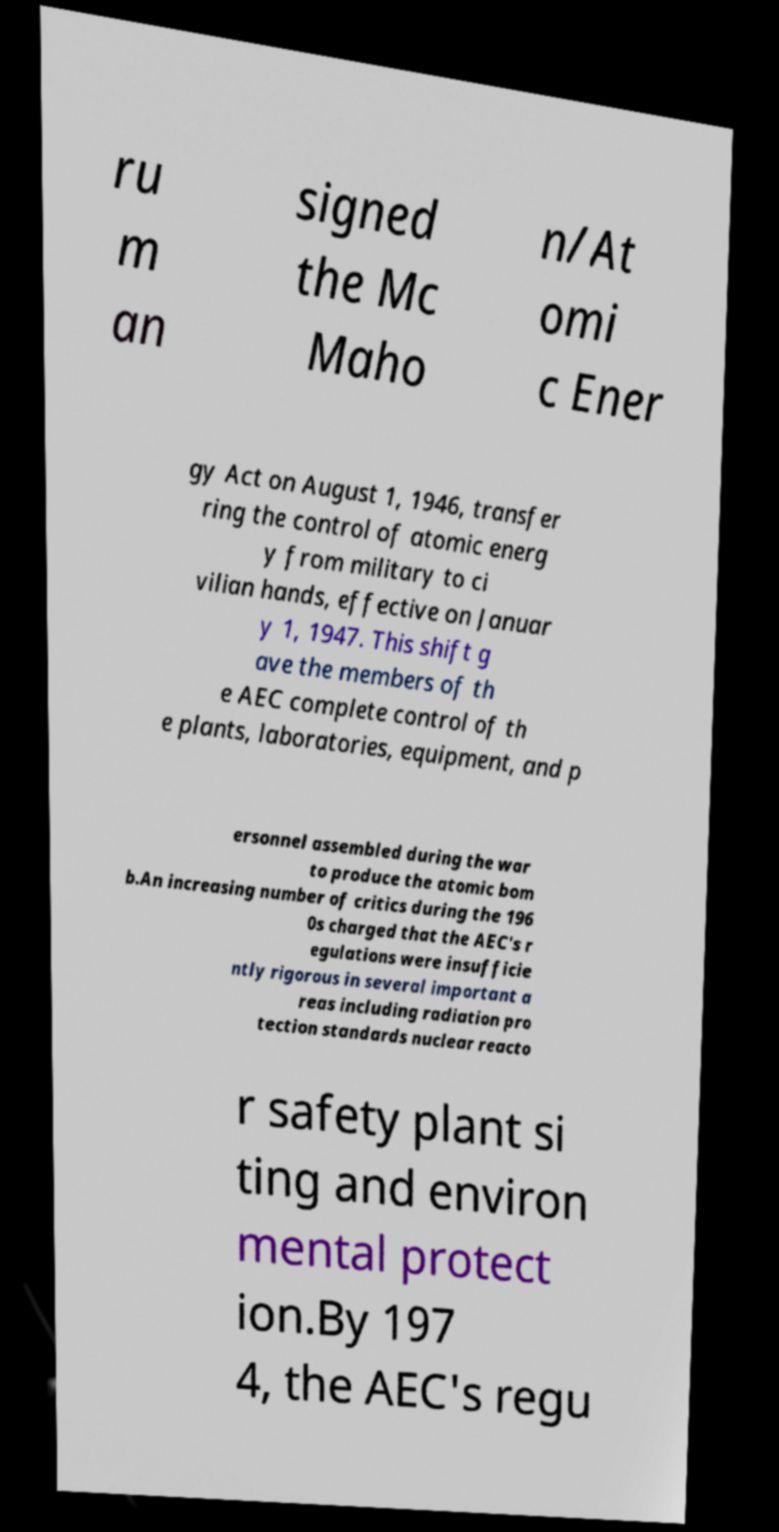Can you read and provide the text displayed in the image?This photo seems to have some interesting text. Can you extract and type it out for me? ru m an signed the Mc Maho n/At omi c Ener gy Act on August 1, 1946, transfer ring the control of atomic energ y from military to ci vilian hands, effective on Januar y 1, 1947. This shift g ave the members of th e AEC complete control of th e plants, laboratories, equipment, and p ersonnel assembled during the war to produce the atomic bom b.An increasing number of critics during the 196 0s charged that the AEC's r egulations were insufficie ntly rigorous in several important a reas including radiation pro tection standards nuclear reacto r safety plant si ting and environ mental protect ion.By 197 4, the AEC's regu 